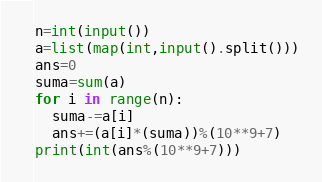<code> <loc_0><loc_0><loc_500><loc_500><_Python_>n=int(input())
a=list(map(int,input().split()))
ans=0
suma=sum(a)
for i in range(n):
  suma-=a[i]
  ans+=(a[i]*(suma))%(10**9+7)
print(int(ans%(10**9+7)))
</code> 